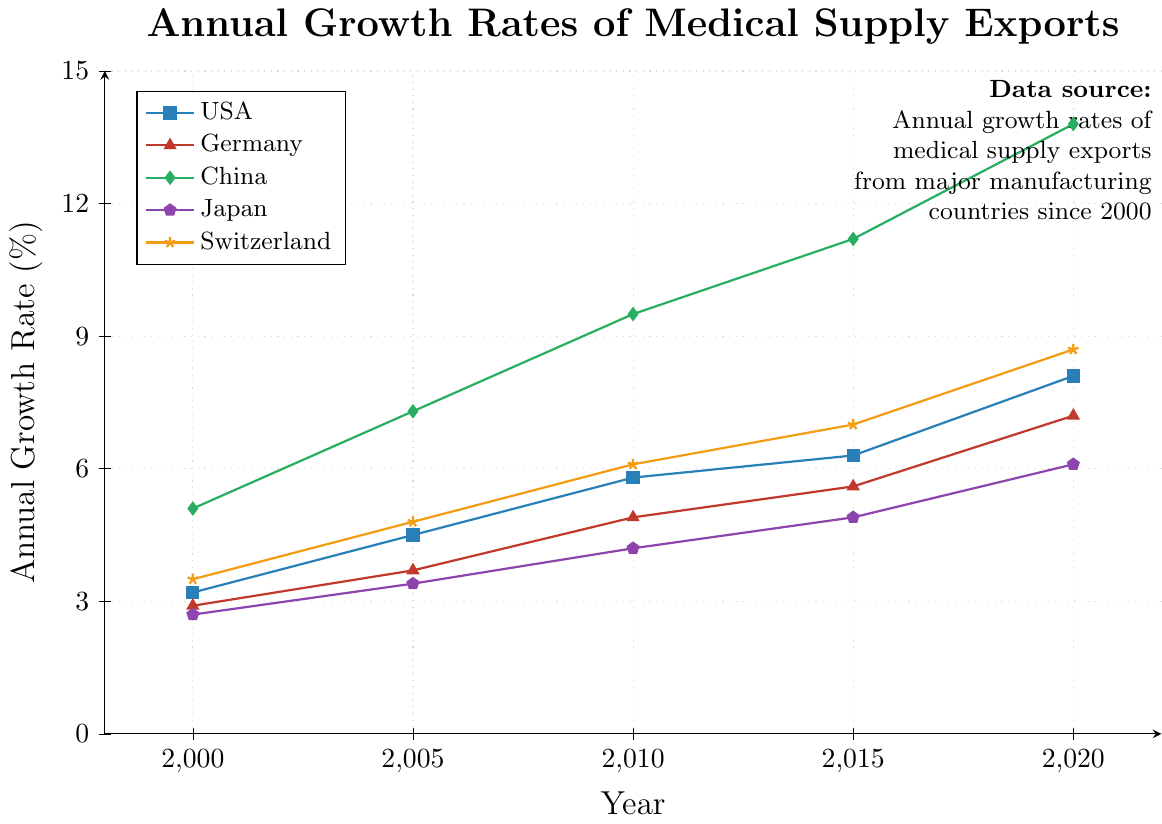Which country had the largest growth rate in 2020? Looking at the y-axis endpoints for each country's line, we can identify that China had the highest point at 2020
Answer: China Which country had the smallest growth rate in 2000? Viewing the y-axis starts for each country's line, Japan has the lowest point in 2000
Answer: Japan By how much did Germany's growth rate increase from 2005 to 2015? Germany's growth rate increased from 3.7% in 2005 to 5.6% in 2015, the difference is 5.6 - 3.7
Answer: 1.9% Which countries had a higher growth rate than the USA in 2010? By comparing the heights of the points at 2010, China (9.5), Switzerland (6.1) are higher than the USA's point (5.8)
Answer: China, Switzerland What's the average growth rate of Japan in the years shown? The sum of Japan’s growth rates is (2.7 + 3.4 + 4.2 + 4.9 + 6.1) which equals 21.3, divided by the number of data points (5)
Answer: 4.26% Which country showed consistent increments every 5 years from 2000 to 2020? By observing the slope of lines between every 5-year interval, only China shows a consistently increasing rate
Answer: China What is the color used to represent Switzerland’s growth rates? Switzerland is indicated with a line color, identified as yellow on the visual
Answer: yellow What was the growth rate difference between USA and China in 2020? The USA had an 8.1% and China had a 13.8% in 2020, the difference is 13.8 - 8.1
Answer: 5.7% What was the overall trend observed for Japan from 2000 to 2020? Generally, Japan shows an increasing trend from 2.7% to 6.1% between 2000 and 2020
Answer: Increasing 